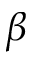Convert formula to latex. <formula><loc_0><loc_0><loc_500><loc_500>\beta</formula> 